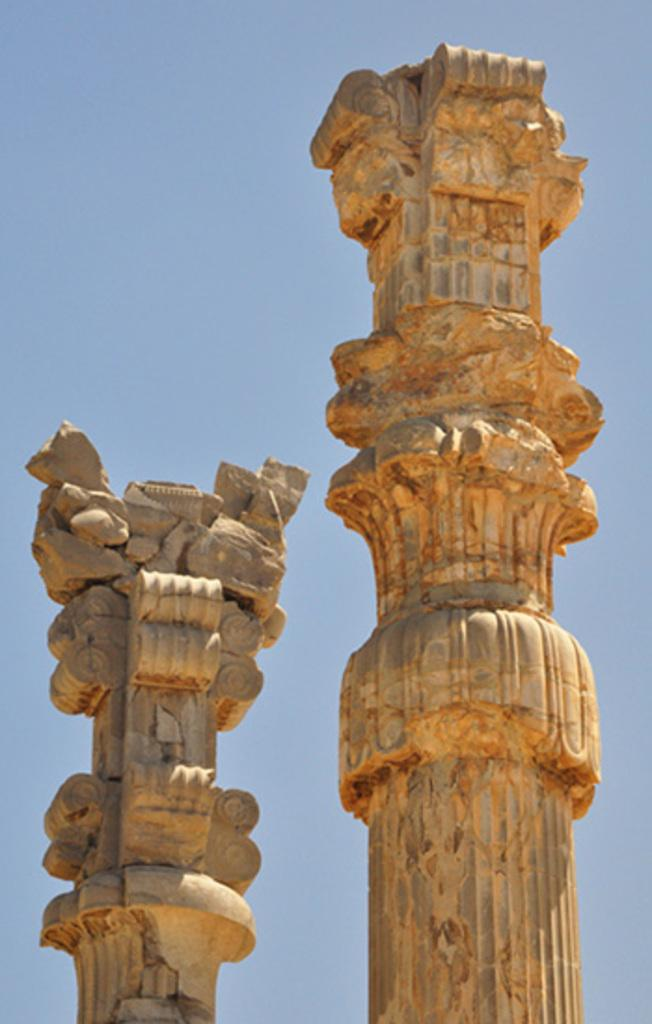How many columns can be seen in the image? There are two columns in the image. What type of sail can be seen on the columns in the image? There is no sail present on the columns in the image. How many cents are visible on the columns in the image? There are no cents visible on the columns in the image. 